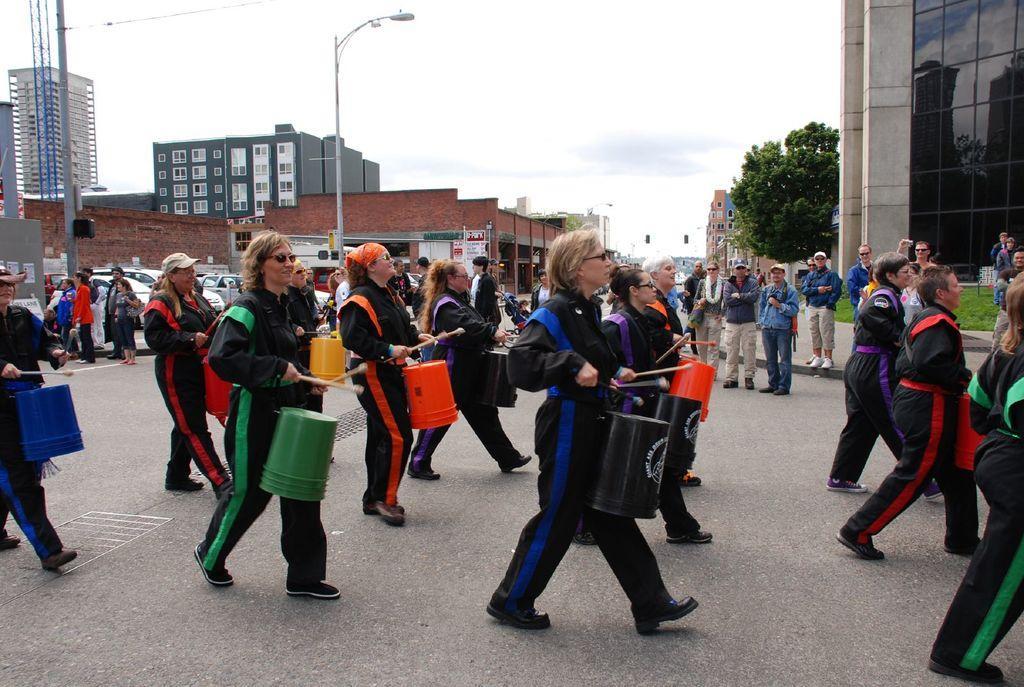In one or two sentences, can you explain what this image depicts? This picture consists of there are few women playing a drum walking on road and there are some persons watching the performance of women ,in the middle there is a street light pole, vehicles ,buildings and some trees,at the top I can see the sky, on the right side I can see the building. 